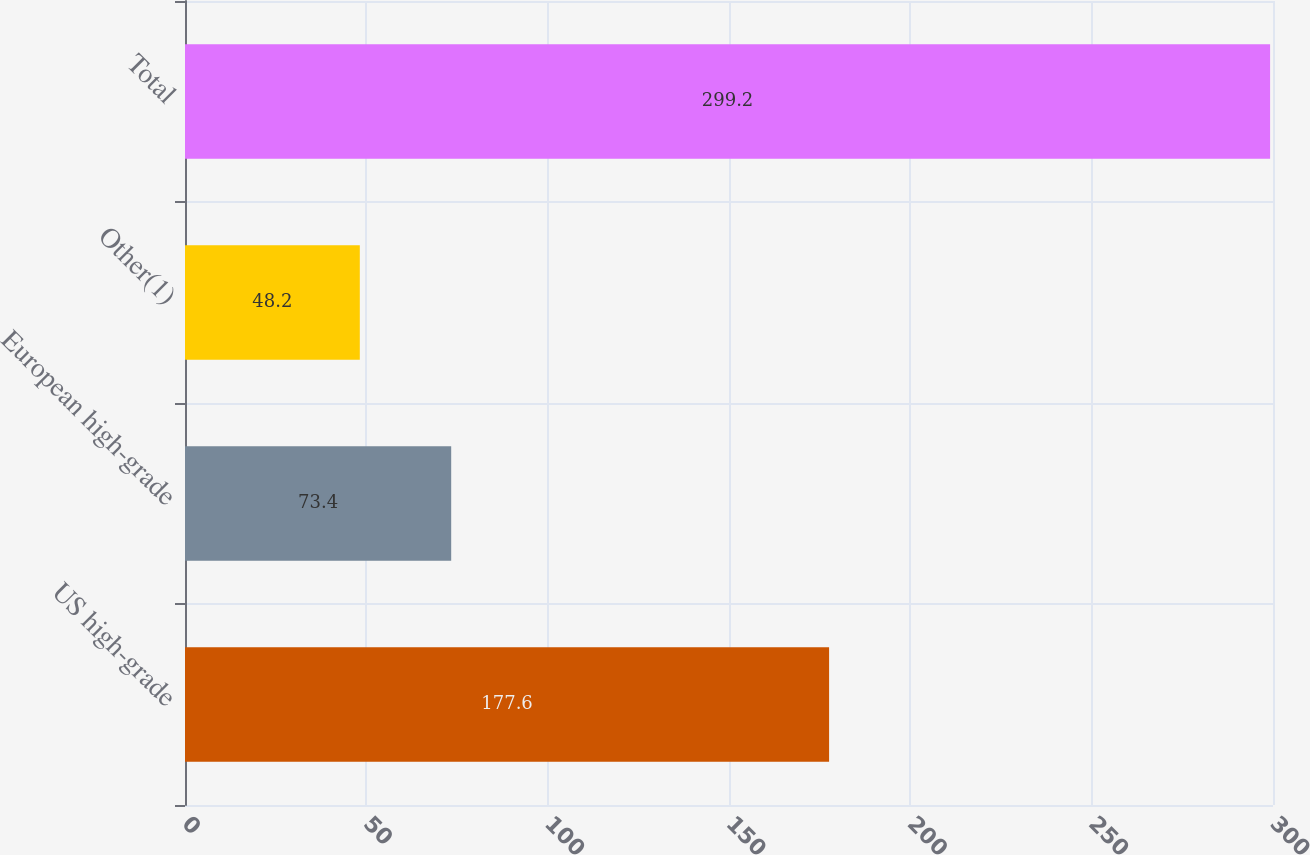<chart> <loc_0><loc_0><loc_500><loc_500><bar_chart><fcel>US high-grade<fcel>European high-grade<fcel>Other(1)<fcel>Total<nl><fcel>177.6<fcel>73.4<fcel>48.2<fcel>299.2<nl></chart> 